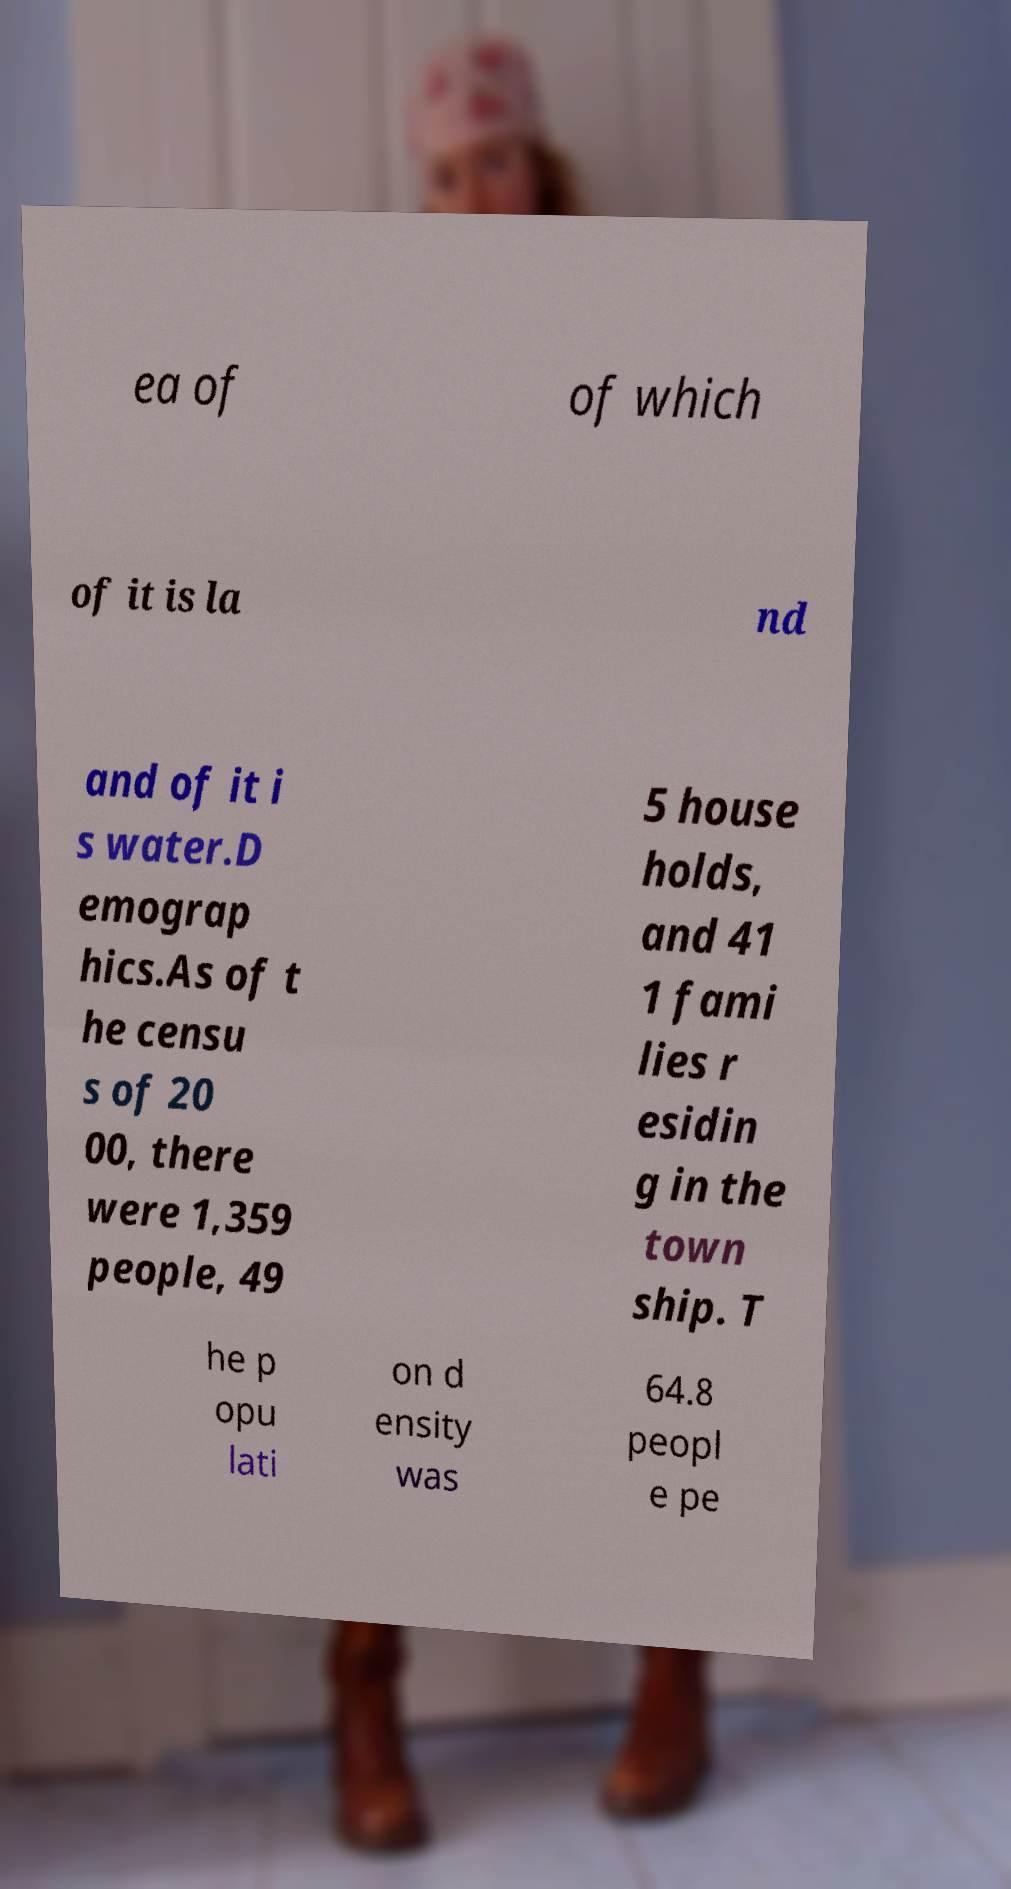Can you accurately transcribe the text from the provided image for me? ea of of which of it is la nd and of it i s water.D emograp hics.As of t he censu s of 20 00, there were 1,359 people, 49 5 house holds, and 41 1 fami lies r esidin g in the town ship. T he p opu lati on d ensity was 64.8 peopl e pe 